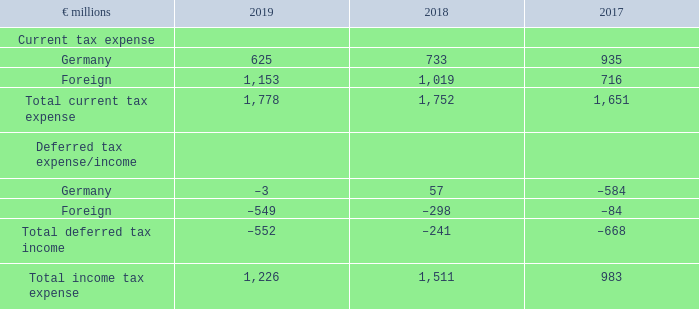(C.5) Income Taxes
Judgments and Estimates
We are subject to changing tax laws in multiple jurisdictions within the countries in which we operate. Our ordinary business activities also include transactions where the ultimate tax outcome is uncertain due to different interpretations of tax laws, such as those involving revenue sharing and cost reimbursement arrangements between SAP Group entities. In addition, the amount of income taxes we pay is generally subject to ongoing audits by domestic and foreign tax authorities. In determining our worldwide income tax provisions, judgment is involved in assessing whether to consider each uncertain tax treatment separately or together with one or more other uncertain tax treatments and whether to reflect the respective effect of uncertainty based on the most likely amount or the expected value. In applying these judgments, we consider the nature and the individual facts and circumstances of each uncertain tax treatment as well as the specifics of the respective jurisdiction, including applicable tax laws and our interpretation thereof.
The assessment whether a deferred tax asset is impaired requires judgment, as we need to estimate future taxable profits to determine whether the utilization of the deferred tax asset is probable. In evaluating our ability to utilize our deferred tax assets, we consider all available positive and negative evidence, including the level of historical taxable income and projections for future taxable income over the periods in which the deferred tax assets are recoverable. Our judgment regarding future taxable income is based on assumptions about future market conditions and future profits of SAP.
Judgment is also required in evaluating whether interest or penalties related to income taxes meet the definition of income taxes, and, if not, whether it is of financial nature. In this judgment, we particularly consider applicable local tax laws and interpretations on IFRS by national standard setters in the area of group financial reporting.
Tax Expense by Geographic Location
What does the table represent? Tax expense by geographic location. In which years was the Tax Expense by Geographic Location calculated? 2019, 2018, 2017. What are the geographic locations in the table considered when calculating the total current tax expense? Germany, foreign. In which year was the current tax expense in Germany the largest? 935>733>625
Answer: 2017. What was the change in current tax expense in Germany in 2019 from 2018?
Answer scale should be: million. 625-733
Answer: -108. What was the percentage change in current tax expense in Germany in 2019 from 2018?
Answer scale should be: percent. (625-733)/733
Answer: -14.73. 